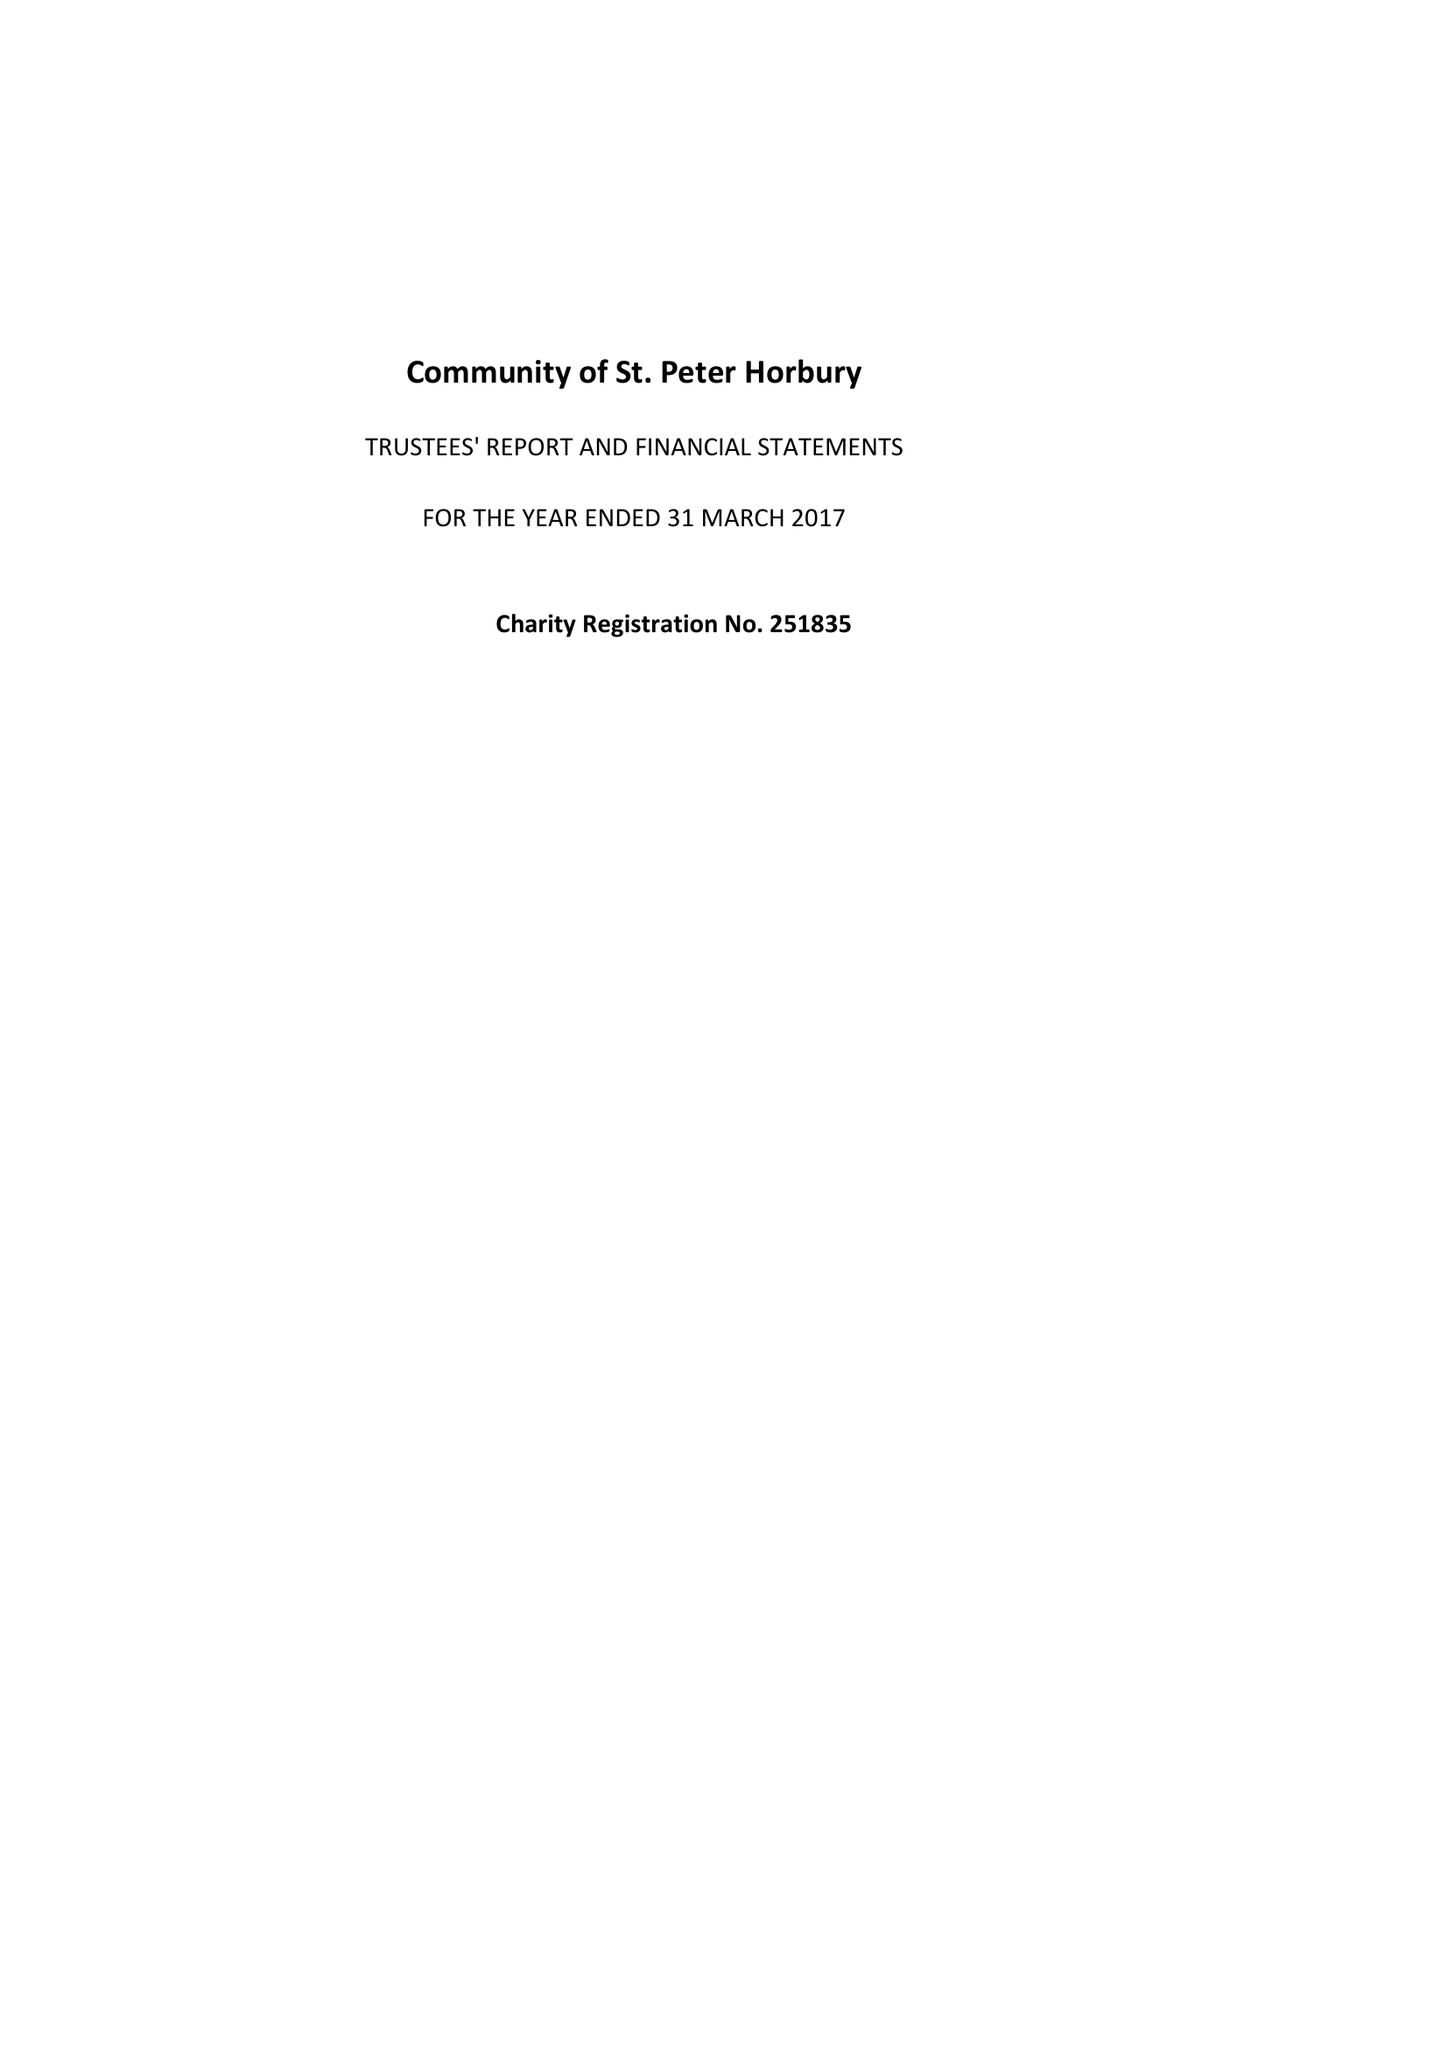What is the value for the report_date?
Answer the question using a single word or phrase. 2017-03-31 